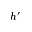Convert formula to latex. <formula><loc_0><loc_0><loc_500><loc_500>h ^ { \prime }</formula> 